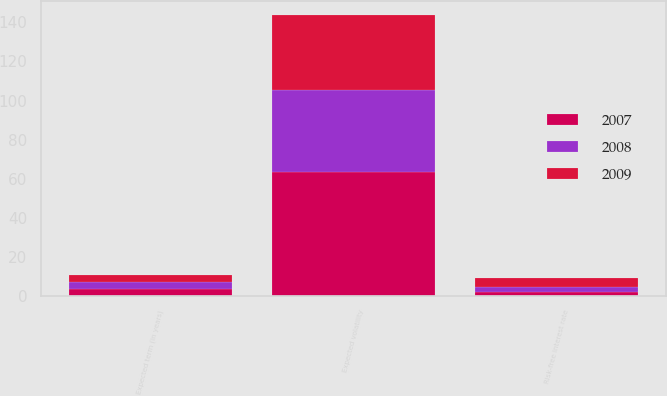Convert chart to OTSL. <chart><loc_0><loc_0><loc_500><loc_500><stacked_bar_chart><ecel><fcel>Expected volatility<fcel>Risk-free interest rate<fcel>Expected term (in years)<nl><fcel>2007<fcel>63.5<fcel>1.8<fcel>3.4<nl><fcel>2008<fcel>41.8<fcel>2.9<fcel>3.6<nl><fcel>2009<fcel>38.6<fcel>4.6<fcel>3.5<nl></chart> 